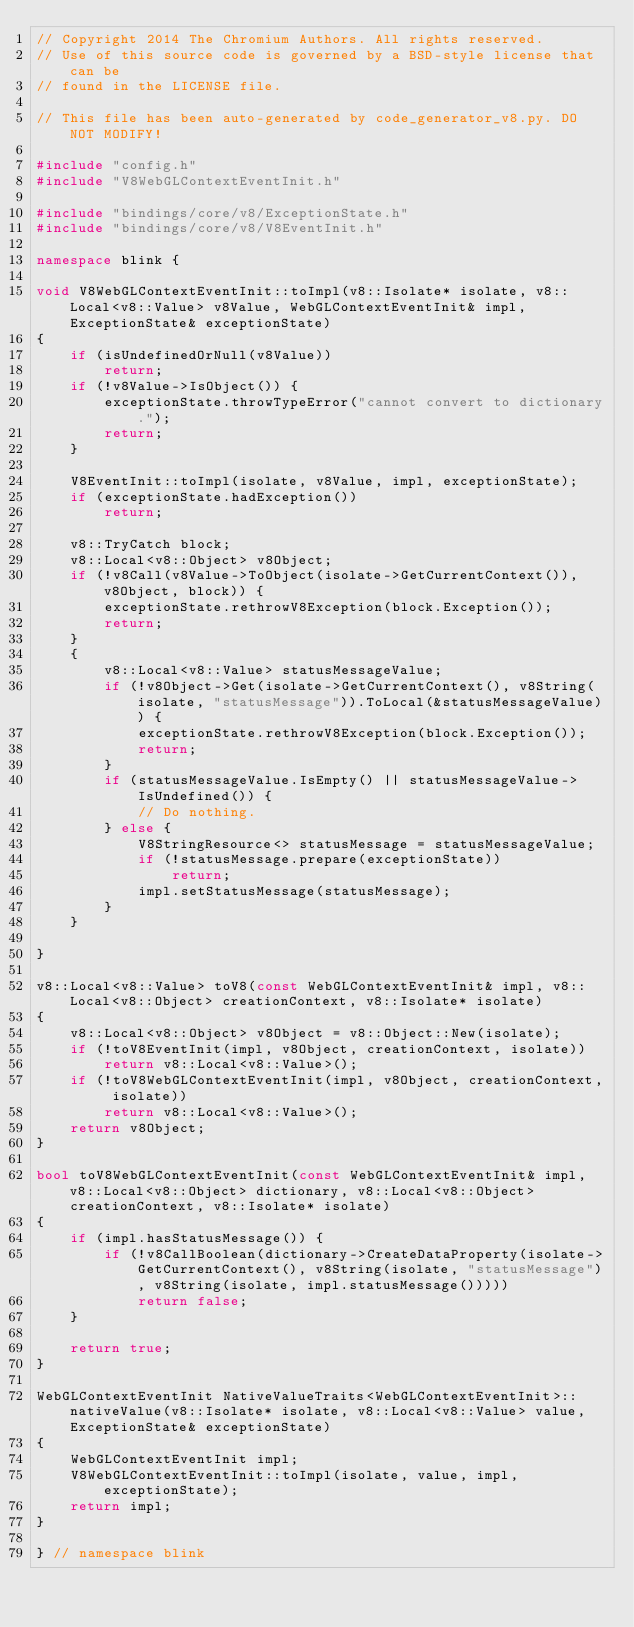<code> <loc_0><loc_0><loc_500><loc_500><_C++_>// Copyright 2014 The Chromium Authors. All rights reserved.
// Use of this source code is governed by a BSD-style license that can be
// found in the LICENSE file.

// This file has been auto-generated by code_generator_v8.py. DO NOT MODIFY!

#include "config.h"
#include "V8WebGLContextEventInit.h"

#include "bindings/core/v8/ExceptionState.h"
#include "bindings/core/v8/V8EventInit.h"

namespace blink {

void V8WebGLContextEventInit::toImpl(v8::Isolate* isolate, v8::Local<v8::Value> v8Value, WebGLContextEventInit& impl, ExceptionState& exceptionState)
{
    if (isUndefinedOrNull(v8Value))
        return;
    if (!v8Value->IsObject()) {
        exceptionState.throwTypeError("cannot convert to dictionary.");
        return;
    }

    V8EventInit::toImpl(isolate, v8Value, impl, exceptionState);
    if (exceptionState.hadException())
        return;

    v8::TryCatch block;
    v8::Local<v8::Object> v8Object;
    if (!v8Call(v8Value->ToObject(isolate->GetCurrentContext()), v8Object, block)) {
        exceptionState.rethrowV8Exception(block.Exception());
        return;
    }
    {
        v8::Local<v8::Value> statusMessageValue;
        if (!v8Object->Get(isolate->GetCurrentContext(), v8String(isolate, "statusMessage")).ToLocal(&statusMessageValue)) {
            exceptionState.rethrowV8Exception(block.Exception());
            return;
        }
        if (statusMessageValue.IsEmpty() || statusMessageValue->IsUndefined()) {
            // Do nothing.
        } else {
            V8StringResource<> statusMessage = statusMessageValue;
            if (!statusMessage.prepare(exceptionState))
                return;
            impl.setStatusMessage(statusMessage);
        }
    }

}

v8::Local<v8::Value> toV8(const WebGLContextEventInit& impl, v8::Local<v8::Object> creationContext, v8::Isolate* isolate)
{
    v8::Local<v8::Object> v8Object = v8::Object::New(isolate);
    if (!toV8EventInit(impl, v8Object, creationContext, isolate))
        return v8::Local<v8::Value>();
    if (!toV8WebGLContextEventInit(impl, v8Object, creationContext, isolate))
        return v8::Local<v8::Value>();
    return v8Object;
}

bool toV8WebGLContextEventInit(const WebGLContextEventInit& impl, v8::Local<v8::Object> dictionary, v8::Local<v8::Object> creationContext, v8::Isolate* isolate)
{
    if (impl.hasStatusMessage()) {
        if (!v8CallBoolean(dictionary->CreateDataProperty(isolate->GetCurrentContext(), v8String(isolate, "statusMessage"), v8String(isolate, impl.statusMessage()))))
            return false;
    }

    return true;
}

WebGLContextEventInit NativeValueTraits<WebGLContextEventInit>::nativeValue(v8::Isolate* isolate, v8::Local<v8::Value> value, ExceptionState& exceptionState)
{
    WebGLContextEventInit impl;
    V8WebGLContextEventInit::toImpl(isolate, value, impl, exceptionState);
    return impl;
}

} // namespace blink
</code> 